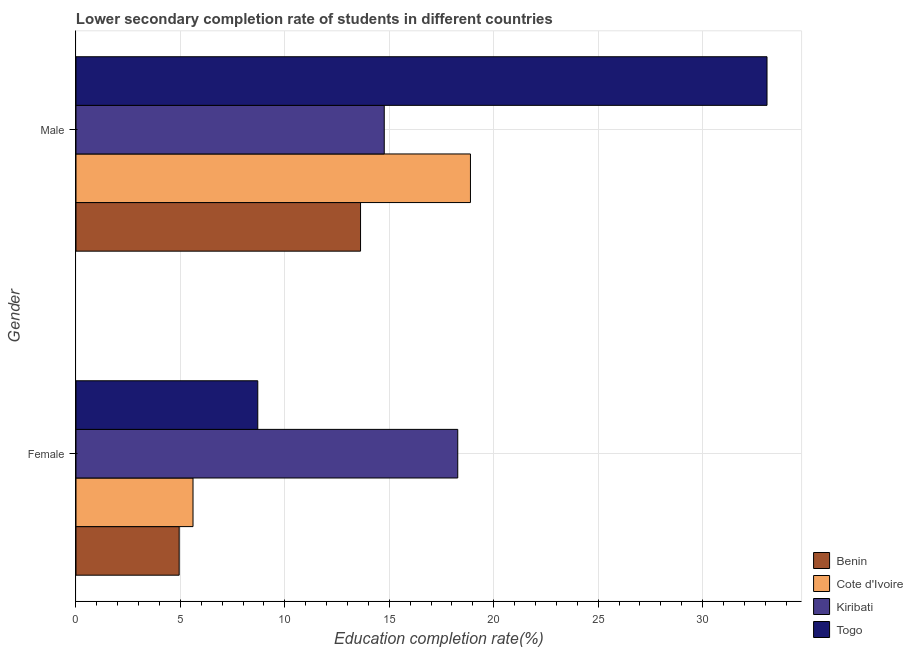How many groups of bars are there?
Ensure brevity in your answer.  2. Are the number of bars per tick equal to the number of legend labels?
Provide a succinct answer. Yes. What is the education completion rate of female students in Togo?
Make the answer very short. 8.7. Across all countries, what is the maximum education completion rate of male students?
Keep it short and to the point. 33.09. Across all countries, what is the minimum education completion rate of female students?
Make the answer very short. 4.94. In which country was the education completion rate of female students maximum?
Make the answer very short. Kiribati. In which country was the education completion rate of male students minimum?
Ensure brevity in your answer.  Benin. What is the total education completion rate of male students in the graph?
Your response must be concise. 80.36. What is the difference between the education completion rate of female students in Togo and that in Benin?
Provide a succinct answer. 3.76. What is the difference between the education completion rate of female students in Togo and the education completion rate of male students in Benin?
Give a very brief answer. -4.92. What is the average education completion rate of female students per country?
Offer a terse response. 9.38. What is the difference between the education completion rate of female students and education completion rate of male students in Benin?
Make the answer very short. -8.68. What is the ratio of the education completion rate of female students in Cote d'Ivoire to that in Togo?
Your response must be concise. 0.64. In how many countries, is the education completion rate of female students greater than the average education completion rate of female students taken over all countries?
Offer a terse response. 1. What does the 1st bar from the top in Female represents?
Provide a succinct answer. Togo. What does the 1st bar from the bottom in Female represents?
Provide a short and direct response. Benin. What is the title of the graph?
Keep it short and to the point. Lower secondary completion rate of students in different countries. What is the label or title of the X-axis?
Offer a very short reply. Education completion rate(%). What is the Education completion rate(%) of Benin in Female?
Your response must be concise. 4.94. What is the Education completion rate(%) in Cote d'Ivoire in Female?
Ensure brevity in your answer.  5.6. What is the Education completion rate(%) of Kiribati in Female?
Provide a succinct answer. 18.28. What is the Education completion rate(%) in Togo in Female?
Your answer should be very brief. 8.7. What is the Education completion rate(%) of Benin in Male?
Your response must be concise. 13.62. What is the Education completion rate(%) in Cote d'Ivoire in Male?
Ensure brevity in your answer.  18.89. What is the Education completion rate(%) of Kiribati in Male?
Offer a very short reply. 14.76. What is the Education completion rate(%) of Togo in Male?
Your response must be concise. 33.09. Across all Gender, what is the maximum Education completion rate(%) in Benin?
Ensure brevity in your answer.  13.62. Across all Gender, what is the maximum Education completion rate(%) in Cote d'Ivoire?
Offer a very short reply. 18.89. Across all Gender, what is the maximum Education completion rate(%) in Kiribati?
Provide a short and direct response. 18.28. Across all Gender, what is the maximum Education completion rate(%) in Togo?
Offer a terse response. 33.09. Across all Gender, what is the minimum Education completion rate(%) in Benin?
Provide a succinct answer. 4.94. Across all Gender, what is the minimum Education completion rate(%) in Cote d'Ivoire?
Your answer should be very brief. 5.6. Across all Gender, what is the minimum Education completion rate(%) in Kiribati?
Keep it short and to the point. 14.76. Across all Gender, what is the minimum Education completion rate(%) in Togo?
Your response must be concise. 8.7. What is the total Education completion rate(%) of Benin in the graph?
Keep it short and to the point. 18.56. What is the total Education completion rate(%) of Cote d'Ivoire in the graph?
Offer a terse response. 24.49. What is the total Education completion rate(%) of Kiribati in the graph?
Make the answer very short. 33.04. What is the total Education completion rate(%) in Togo in the graph?
Provide a short and direct response. 41.79. What is the difference between the Education completion rate(%) of Benin in Female and that in Male?
Keep it short and to the point. -8.68. What is the difference between the Education completion rate(%) in Cote d'Ivoire in Female and that in Male?
Provide a succinct answer. -13.28. What is the difference between the Education completion rate(%) of Kiribati in Female and that in Male?
Ensure brevity in your answer.  3.52. What is the difference between the Education completion rate(%) of Togo in Female and that in Male?
Offer a very short reply. -24.38. What is the difference between the Education completion rate(%) in Benin in Female and the Education completion rate(%) in Cote d'Ivoire in Male?
Offer a very short reply. -13.95. What is the difference between the Education completion rate(%) of Benin in Female and the Education completion rate(%) of Kiribati in Male?
Your response must be concise. -9.82. What is the difference between the Education completion rate(%) of Benin in Female and the Education completion rate(%) of Togo in Male?
Provide a succinct answer. -28.15. What is the difference between the Education completion rate(%) in Cote d'Ivoire in Female and the Education completion rate(%) in Kiribati in Male?
Give a very brief answer. -9.16. What is the difference between the Education completion rate(%) of Cote d'Ivoire in Female and the Education completion rate(%) of Togo in Male?
Ensure brevity in your answer.  -27.48. What is the difference between the Education completion rate(%) of Kiribati in Female and the Education completion rate(%) of Togo in Male?
Make the answer very short. -14.81. What is the average Education completion rate(%) in Benin per Gender?
Keep it short and to the point. 9.28. What is the average Education completion rate(%) of Cote d'Ivoire per Gender?
Make the answer very short. 12.24. What is the average Education completion rate(%) of Kiribati per Gender?
Make the answer very short. 16.52. What is the average Education completion rate(%) of Togo per Gender?
Provide a succinct answer. 20.89. What is the difference between the Education completion rate(%) in Benin and Education completion rate(%) in Cote d'Ivoire in Female?
Keep it short and to the point. -0.66. What is the difference between the Education completion rate(%) in Benin and Education completion rate(%) in Kiribati in Female?
Give a very brief answer. -13.34. What is the difference between the Education completion rate(%) of Benin and Education completion rate(%) of Togo in Female?
Your response must be concise. -3.76. What is the difference between the Education completion rate(%) of Cote d'Ivoire and Education completion rate(%) of Kiribati in Female?
Your answer should be very brief. -12.67. What is the difference between the Education completion rate(%) in Cote d'Ivoire and Education completion rate(%) in Togo in Female?
Provide a short and direct response. -3.1. What is the difference between the Education completion rate(%) of Kiribati and Education completion rate(%) of Togo in Female?
Ensure brevity in your answer.  9.57. What is the difference between the Education completion rate(%) of Benin and Education completion rate(%) of Cote d'Ivoire in Male?
Give a very brief answer. -5.26. What is the difference between the Education completion rate(%) in Benin and Education completion rate(%) in Kiribati in Male?
Keep it short and to the point. -1.13. What is the difference between the Education completion rate(%) in Benin and Education completion rate(%) in Togo in Male?
Provide a short and direct response. -19.46. What is the difference between the Education completion rate(%) of Cote d'Ivoire and Education completion rate(%) of Kiribati in Male?
Offer a terse response. 4.13. What is the difference between the Education completion rate(%) in Cote d'Ivoire and Education completion rate(%) in Togo in Male?
Keep it short and to the point. -14.2. What is the difference between the Education completion rate(%) of Kiribati and Education completion rate(%) of Togo in Male?
Offer a very short reply. -18.33. What is the ratio of the Education completion rate(%) in Benin in Female to that in Male?
Your answer should be compact. 0.36. What is the ratio of the Education completion rate(%) in Cote d'Ivoire in Female to that in Male?
Provide a short and direct response. 0.3. What is the ratio of the Education completion rate(%) of Kiribati in Female to that in Male?
Your response must be concise. 1.24. What is the ratio of the Education completion rate(%) in Togo in Female to that in Male?
Your response must be concise. 0.26. What is the difference between the highest and the second highest Education completion rate(%) in Benin?
Your response must be concise. 8.68. What is the difference between the highest and the second highest Education completion rate(%) in Cote d'Ivoire?
Your answer should be very brief. 13.28. What is the difference between the highest and the second highest Education completion rate(%) of Kiribati?
Offer a terse response. 3.52. What is the difference between the highest and the second highest Education completion rate(%) of Togo?
Keep it short and to the point. 24.38. What is the difference between the highest and the lowest Education completion rate(%) of Benin?
Your answer should be very brief. 8.68. What is the difference between the highest and the lowest Education completion rate(%) of Cote d'Ivoire?
Offer a terse response. 13.28. What is the difference between the highest and the lowest Education completion rate(%) of Kiribati?
Your answer should be compact. 3.52. What is the difference between the highest and the lowest Education completion rate(%) of Togo?
Give a very brief answer. 24.38. 